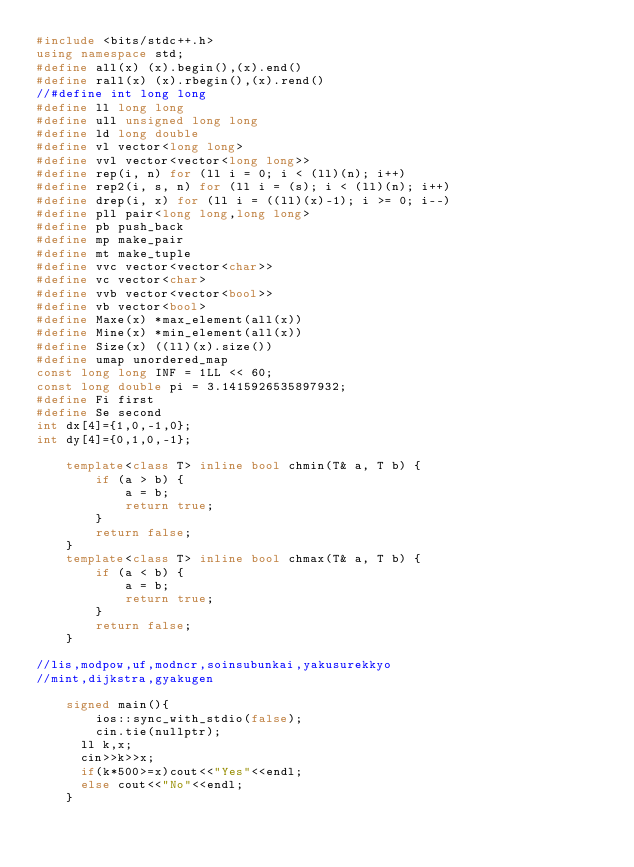<code> <loc_0><loc_0><loc_500><loc_500><_C++_>#include <bits/stdc++.h>
using namespace std;
#define all(x) (x).begin(),(x).end()
#define rall(x) (x).rbegin(),(x).rend()
//#define int long long
#define ll long long
#define ull unsigned long long
#define ld long double
#define vl vector<long long>
#define vvl vector<vector<long long>>
#define rep(i, n) for (ll i = 0; i < (ll)(n); i++)
#define rep2(i, s, n) for (ll i = (s); i < (ll)(n); i++)
#define drep(i, x) for (ll i = ((ll)(x)-1); i >= 0; i--)
#define pll pair<long long,long long>
#define pb push_back
#define mp make_pair
#define mt make_tuple
#define vvc vector<vector<char>>
#define vc vector<char>
#define vvb vector<vector<bool>>
#define vb vector<bool>
#define Maxe(x) *max_element(all(x))
#define Mine(x) *min_element(all(x))
#define Size(x) ((ll)(x).size())
#define umap unordered_map
const long long INF = 1LL << 60;
const long double pi = 3.1415926535897932;
#define Fi first
#define Se second
int dx[4]={1,0,-1,0};
int dy[4]={0,1,0,-1};

    template<class T> inline bool chmin(T& a, T b) {
        if (a > b) {
            a = b;
            return true;
        }
        return false;
    }
    template<class T> inline bool chmax(T& a, T b) {
        if (a < b) {
            a = b;
            return true;
        }
        return false;
    }

//lis,modpow,uf,modncr,soinsubunkai,yakusurekkyo
//mint,dijkstra,gyakugen

    signed main(){
        ios::sync_with_stdio(false);
        cin.tie(nullptr);
      ll k,x;
      cin>>k>>x;
      if(k*500>=x)cout<<"Yes"<<endl;
      else cout<<"No"<<endl;
    }</code> 